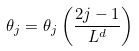<formula> <loc_0><loc_0><loc_500><loc_500>\theta _ { j } = \theta _ { j } \left ( \frac { 2 j - 1 } { L ^ { d } } \right )</formula> 